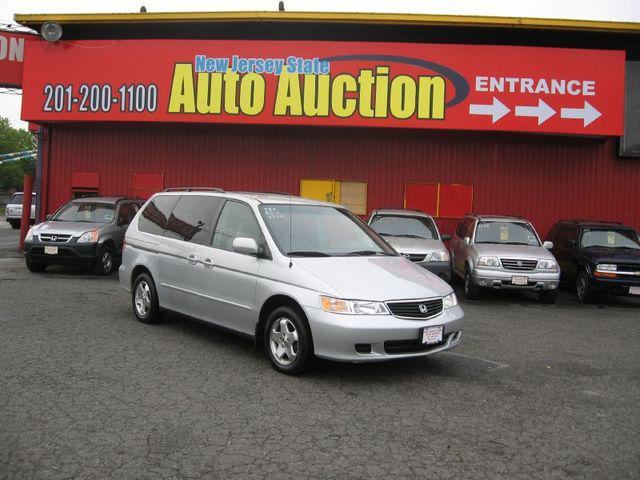Describe the appearance and condition of the silver van parked in the foreground. The silver van in the foreground appears to be a well-maintained, late-model minivan with no visible damage. It's parked prominently in the lot, suggesting it may be a featured vehicle at this auto auction house. 